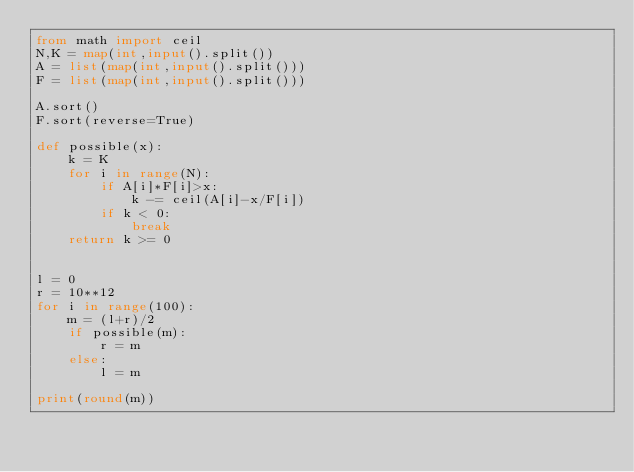<code> <loc_0><loc_0><loc_500><loc_500><_Python_>from math import ceil
N,K = map(int,input().split())
A = list(map(int,input().split()))
F = list(map(int,input().split()))

A.sort()
F.sort(reverse=True)

def possible(x):
    k = K
    for i in range(N):
        if A[i]*F[i]>x:
            k -= ceil(A[i]-x/F[i])
        if k < 0:
            break
    return k >= 0


l = 0
r = 10**12
for i in range(100):
    m = (l+r)/2
    if possible(m):
        r = m
    else:
        l = m

print(round(m))</code> 